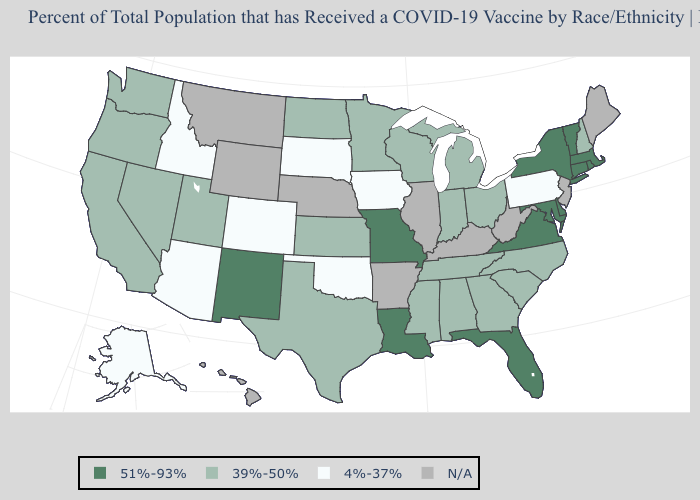Is the legend a continuous bar?
Be succinct. No. Name the states that have a value in the range 39%-50%?
Keep it brief. Alabama, California, Georgia, Indiana, Kansas, Michigan, Minnesota, Mississippi, Nevada, New Hampshire, North Carolina, North Dakota, Ohio, Oregon, South Carolina, Tennessee, Texas, Utah, Washington, Wisconsin. Does New Mexico have the highest value in the West?
Give a very brief answer. Yes. What is the highest value in states that border North Dakota?
Give a very brief answer. 39%-50%. Does the first symbol in the legend represent the smallest category?
Short answer required. No. Is the legend a continuous bar?
Short answer required. No. What is the value of Wisconsin?
Be succinct. 39%-50%. What is the highest value in the West ?
Give a very brief answer. 51%-93%. Among the states that border South Dakota , does Minnesota have the lowest value?
Answer briefly. No. Does Vermont have the highest value in the USA?
Keep it brief. Yes. Name the states that have a value in the range 51%-93%?
Keep it brief. Connecticut, Delaware, Florida, Louisiana, Maryland, Massachusetts, Missouri, New Mexico, New York, Rhode Island, Vermont, Virginia. What is the value of Indiana?
Quick response, please. 39%-50%. What is the highest value in the MidWest ?
Write a very short answer. 51%-93%. Which states have the highest value in the USA?
Concise answer only. Connecticut, Delaware, Florida, Louisiana, Maryland, Massachusetts, Missouri, New Mexico, New York, Rhode Island, Vermont, Virginia. Does Oregon have the lowest value in the West?
Write a very short answer. No. 